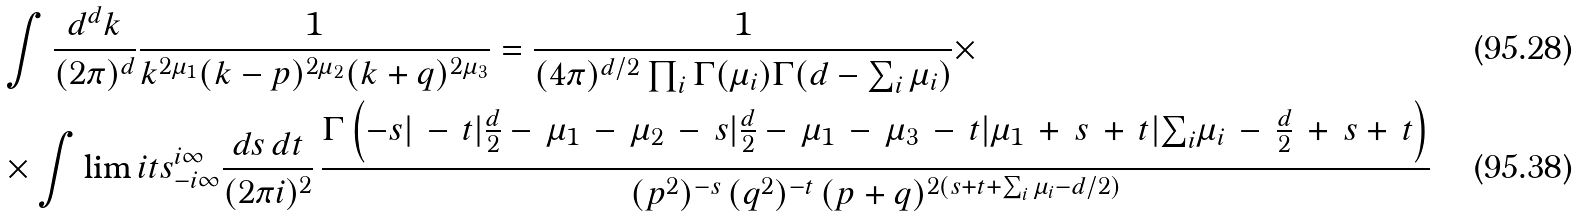<formula> <loc_0><loc_0><loc_500><loc_500>& \int \frac { d ^ { d } k } { ( 2 \pi ) ^ { d } } \frac { 1 } { k ^ { 2 \mu _ { 1 } } ( k - p ) ^ { 2 \mu _ { 2 } } ( k + q ) ^ { 2 \mu _ { 3 } } } = \frac { 1 } { ( 4 \pi ) ^ { d / 2 } \prod _ { i } \Gamma ( \mu _ { i } ) \Gamma ( d - \sum _ { i } \mu _ { i } ) } \times \\ & \times \int \lim i t s _ { - i \infty } ^ { i \infty } \frac { d { s } \, d { t } } { ( 2 \pi i ) ^ { 2 } } \, \frac { \Gamma \left ( - { s } | \, - \, { t } | \frac { d } { 2 } - \, \mu _ { 1 } \, - \, \mu _ { 2 } \, - \, { s } | \frac { d } { 2 } - \, \mu _ { 1 } \, - \, \mu _ { 3 } \, - \, { t } | \mu _ { 1 } \, + \, { s } \, + \, { t } | { \sum } _ { i } \mu _ { i } \, - \, \frac { d } { 2 } \, + \, { s } + \, { t } \right ) } { ( p ^ { 2 } ) ^ { - { s } } \, ( q ^ { 2 } ) ^ { - { t } } \, ( p + q ) ^ { 2 ( { s } + { t } + \sum _ { i } \mu _ { i } - d / 2 ) } }</formula> 